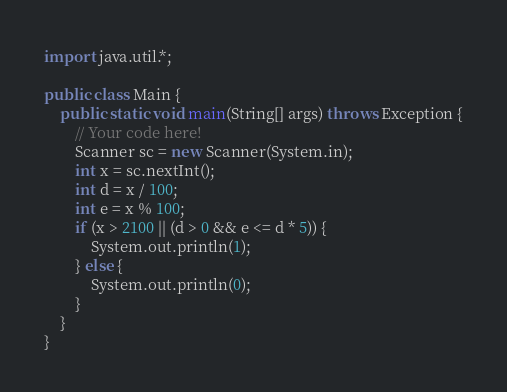<code> <loc_0><loc_0><loc_500><loc_500><_Java_>import java.util.*;

public class Main {
    public static void main(String[] args) throws Exception {
        // Your code here!
        Scanner sc = new Scanner(System.in);
        int x = sc.nextInt();
        int d = x / 100;
        int e = x % 100;
        if (x > 2100 || (d > 0 && e <= d * 5)) {
            System.out.println(1);
        } else {
            System.out.println(0);
        }
    }
}
</code> 